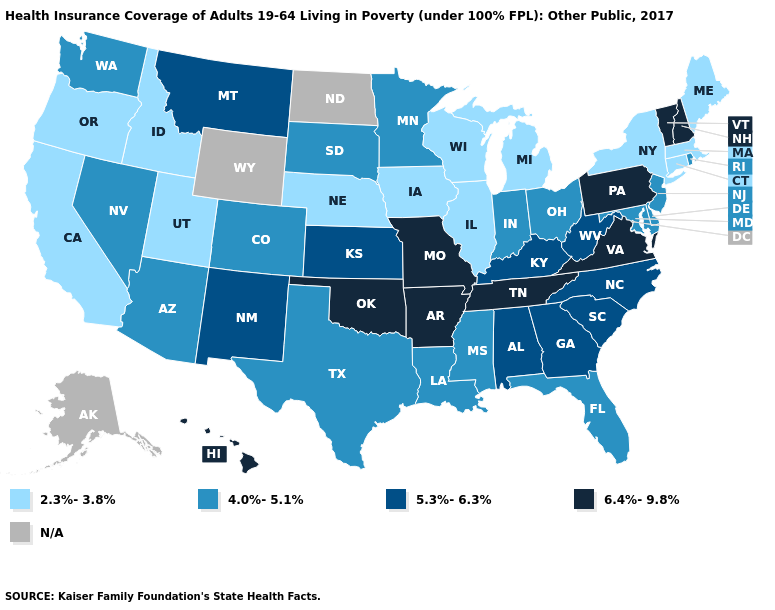Which states hav the highest value in the South?
Answer briefly. Arkansas, Oklahoma, Tennessee, Virginia. Does Florida have the lowest value in the South?
Answer briefly. Yes. What is the value of New Mexico?
Short answer required. 5.3%-6.3%. Among the states that border Washington , which have the lowest value?
Write a very short answer. Idaho, Oregon. Among the states that border Alabama , does Florida have the lowest value?
Answer briefly. Yes. Among the states that border Montana , does Idaho have the lowest value?
Write a very short answer. Yes. How many symbols are there in the legend?
Give a very brief answer. 5. How many symbols are there in the legend?
Write a very short answer. 5. Does Missouri have the highest value in the MidWest?
Short answer required. Yes. Which states have the lowest value in the MidWest?
Write a very short answer. Illinois, Iowa, Michigan, Nebraska, Wisconsin. Does the map have missing data?
Give a very brief answer. Yes. What is the value of Colorado?
Short answer required. 4.0%-5.1%. Does Missouri have the highest value in the MidWest?
Write a very short answer. Yes. What is the highest value in the USA?
Give a very brief answer. 6.4%-9.8%. 